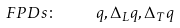<formula> <loc_0><loc_0><loc_500><loc_500>F P D s \colon \quad q , \Delta _ { L } q , \Delta _ { T } q</formula> 